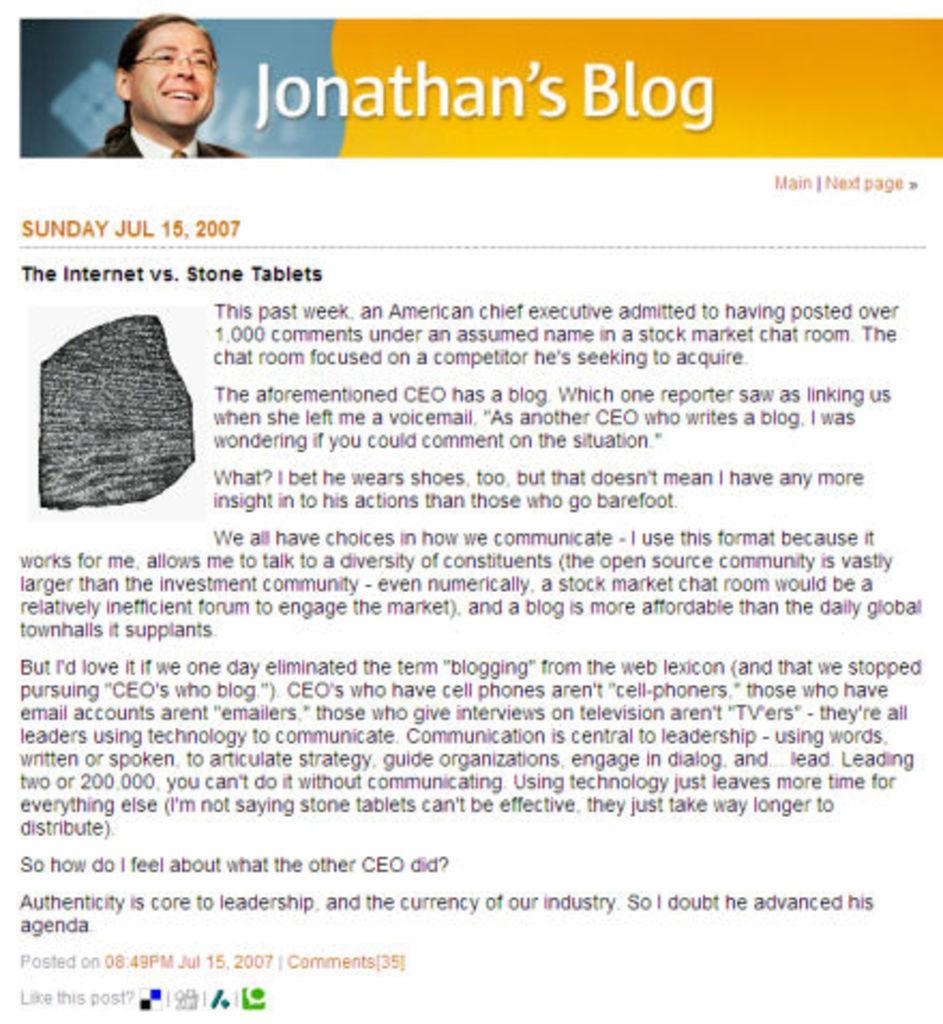Could you give a brief overview of what you see in this image? In this image there is a screenshot of page in which there is a person image, rock and some text. 